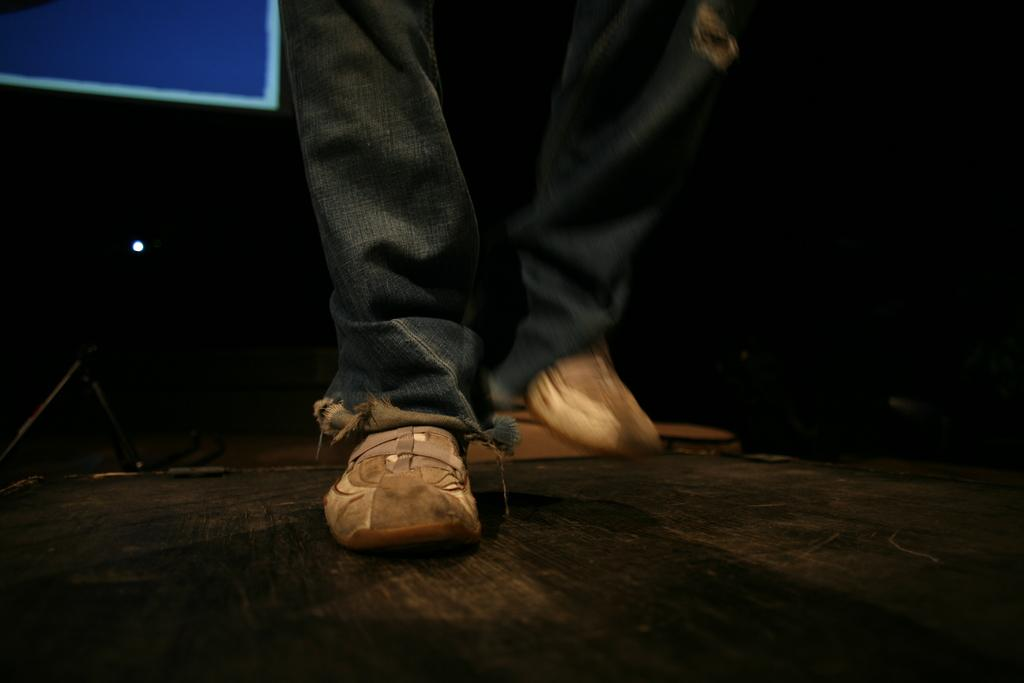What part of a person can be seen in the image? There are legs of a person in the image. Where are the legs located? The legs are on a platform. What can be observed about the background of the image? The background of the image is dark. How does the person's brother help them start their day in the image? There is no reference to a brother or any activity related to starting the day in the image. 